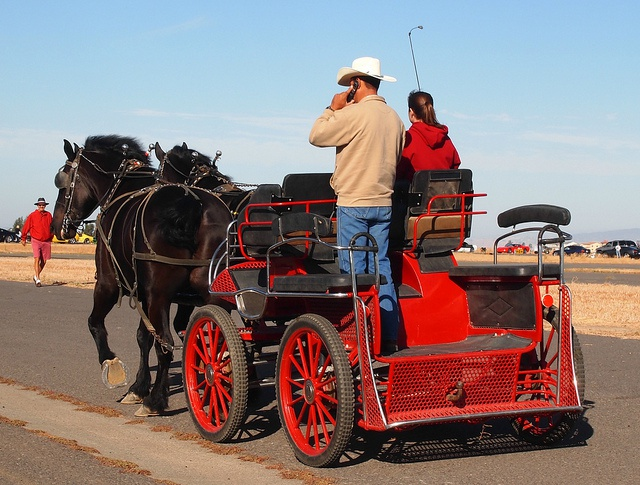Describe the objects in this image and their specific colors. I can see horse in lightblue, black, and gray tones, people in lightblue, tan, black, and gray tones, chair in lightblue, black, gray, and maroon tones, chair in lightblue, black, gray, lightgray, and maroon tones, and chair in lightblue, black, maroon, and brown tones in this image. 